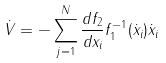<formula> <loc_0><loc_0><loc_500><loc_500>\dot { V } = - \sum _ { j = 1 } ^ { N } \frac { d f _ { 2 } } { d x _ { i } } f _ { 1 } ^ { - 1 } ( \dot { x } _ { i } ) \dot { x } _ { i }</formula> 